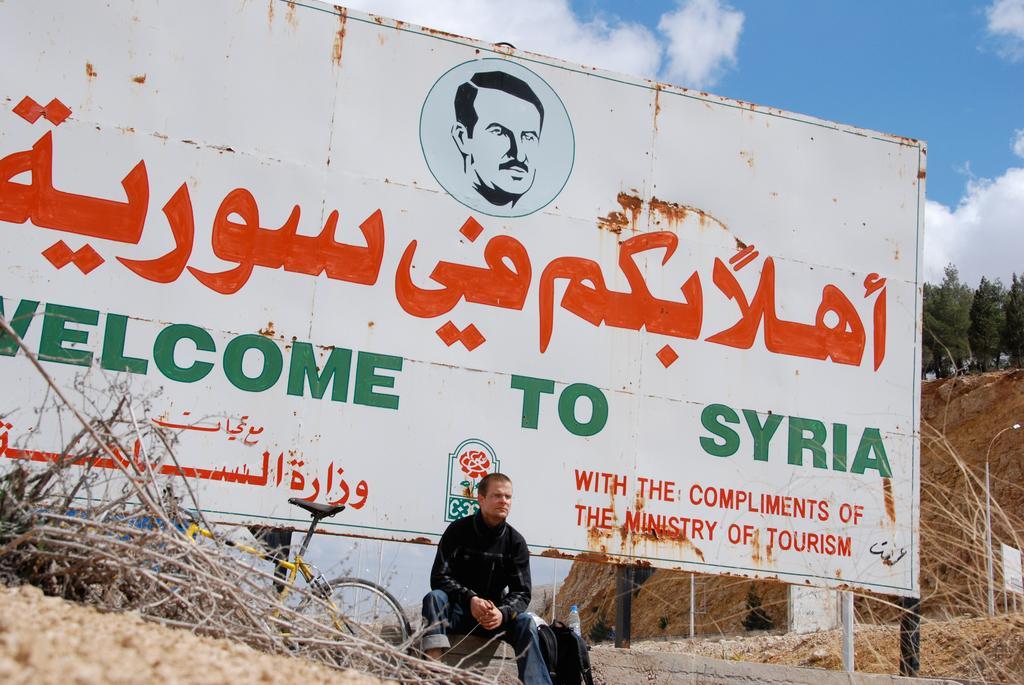How would you summarize this image in a sentence or two? In this image I can see a person wearing black shirt, blue pant and black color bag. Background I can see a board in white color, trees in green color and the sky is in white and blue color. 